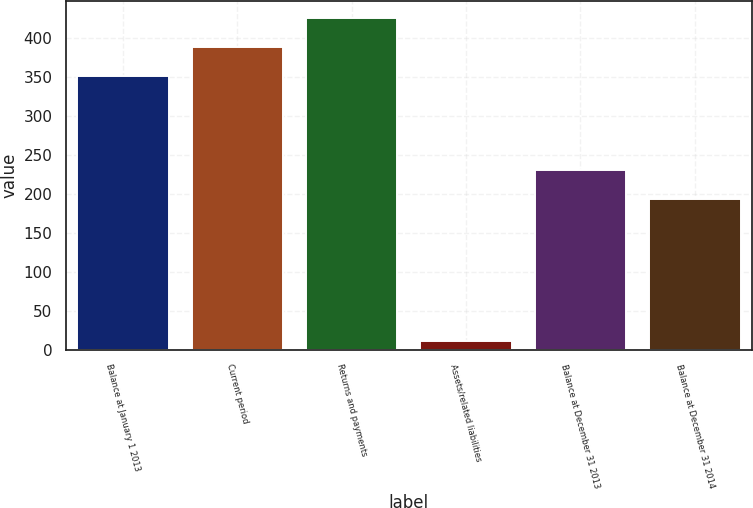Convert chart to OTSL. <chart><loc_0><loc_0><loc_500><loc_500><bar_chart><fcel>Balance at January 1 2013<fcel>Current period<fcel>Returns and payments<fcel>Assets/related liabilities<fcel>Balance at December 31 2013<fcel>Balance at December 31 2014<nl><fcel>351<fcel>388.7<fcel>426.4<fcel>11<fcel>230.7<fcel>193<nl></chart> 